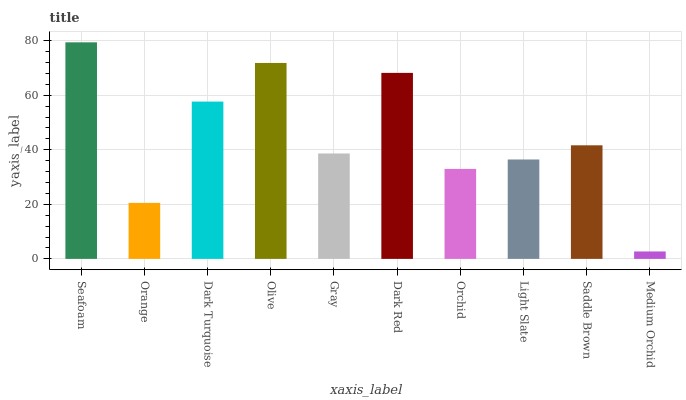Is Medium Orchid the minimum?
Answer yes or no. Yes. Is Seafoam the maximum?
Answer yes or no. Yes. Is Orange the minimum?
Answer yes or no. No. Is Orange the maximum?
Answer yes or no. No. Is Seafoam greater than Orange?
Answer yes or no. Yes. Is Orange less than Seafoam?
Answer yes or no. Yes. Is Orange greater than Seafoam?
Answer yes or no. No. Is Seafoam less than Orange?
Answer yes or no. No. Is Saddle Brown the high median?
Answer yes or no. Yes. Is Gray the low median?
Answer yes or no. Yes. Is Dark Red the high median?
Answer yes or no. No. Is Medium Orchid the low median?
Answer yes or no. No. 